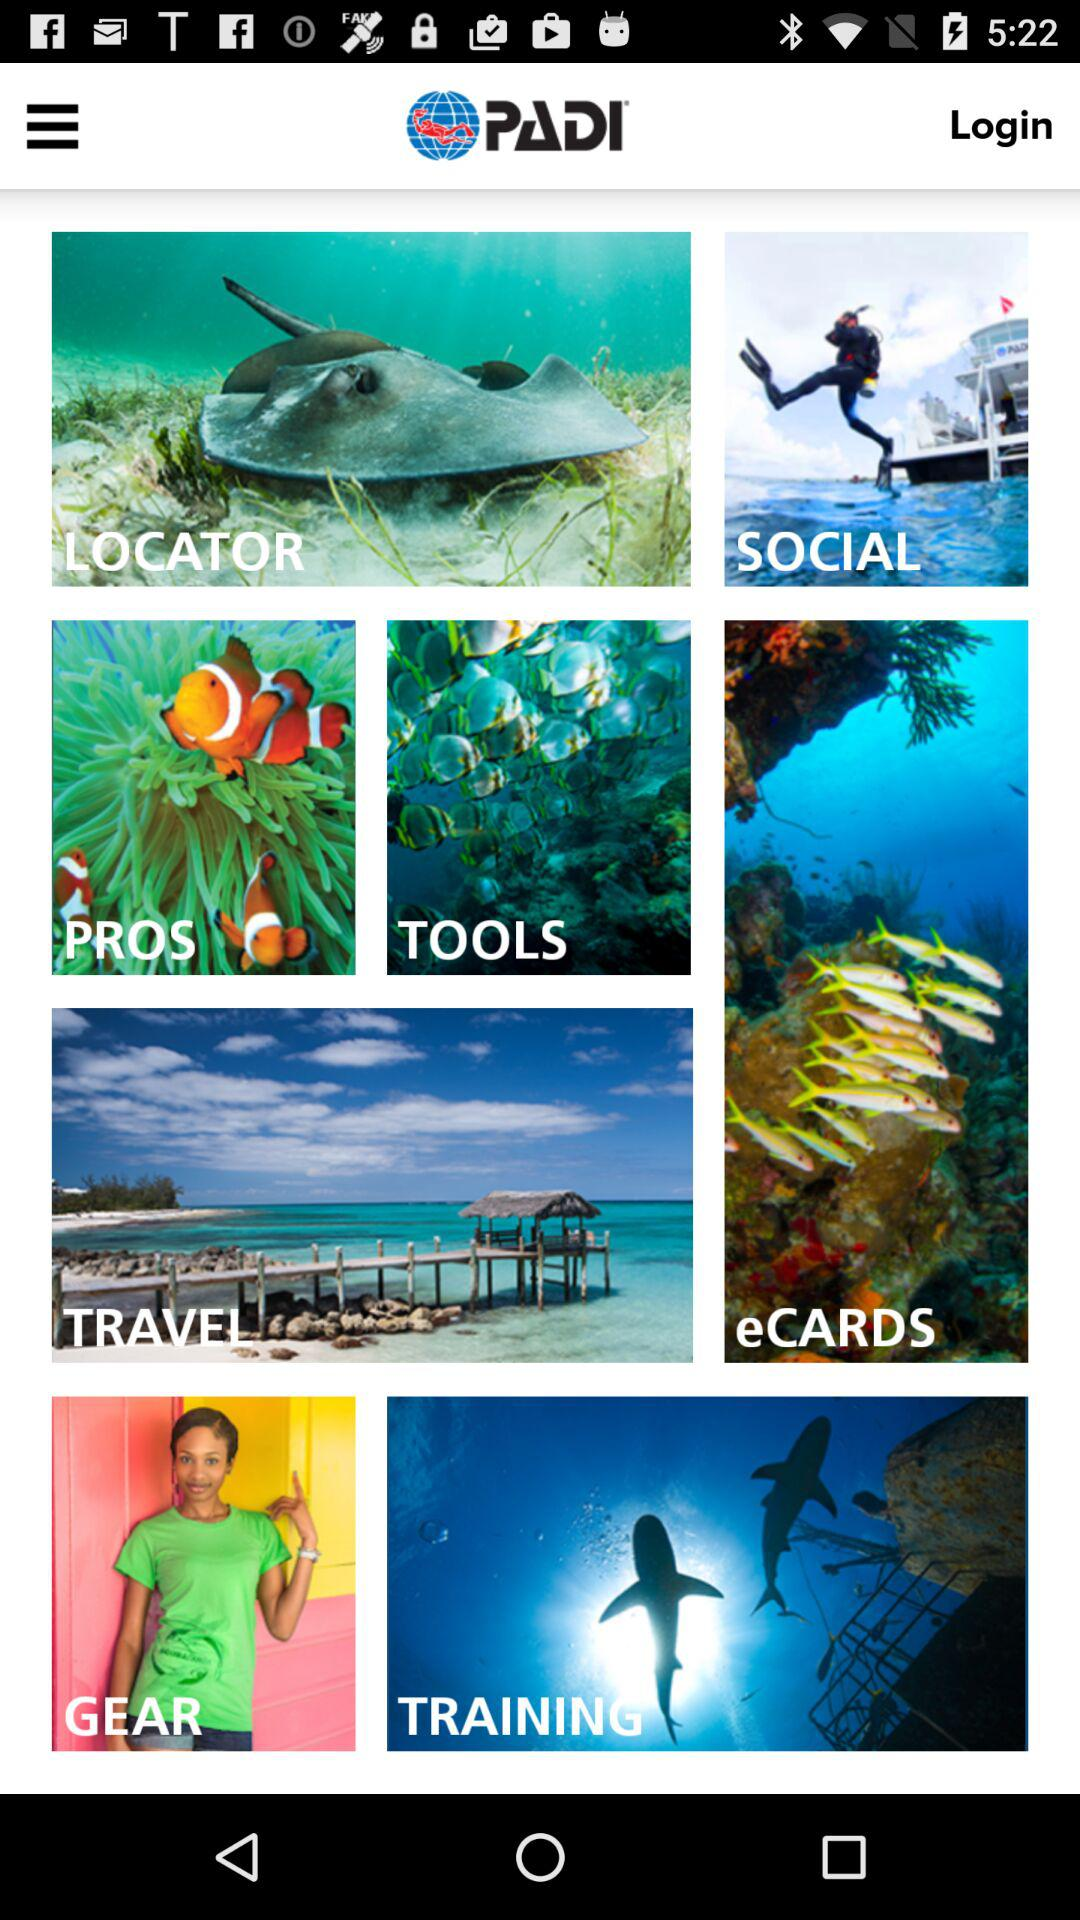What email is used to log into the account?
When the provided information is insufficient, respond with <no answer>. <no answer> 